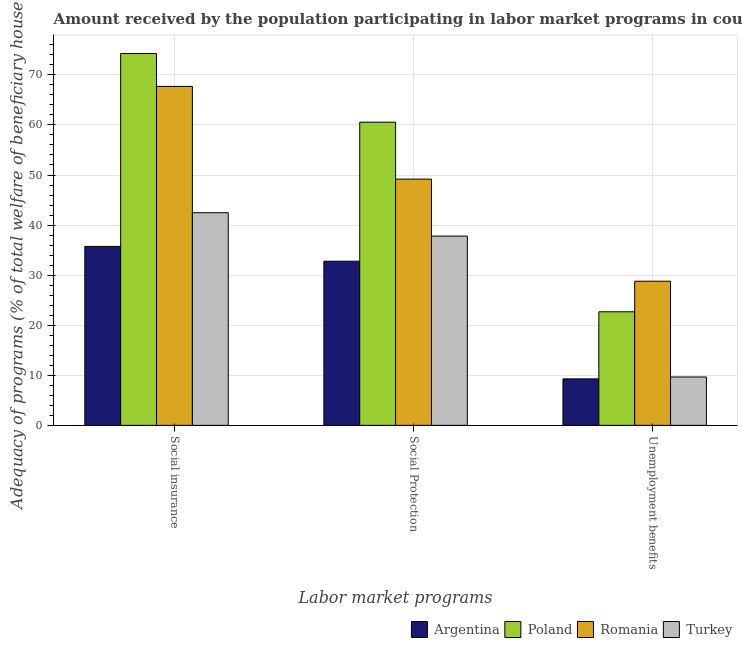Are the number of bars per tick equal to the number of legend labels?
Keep it short and to the point. Yes. How many bars are there on the 2nd tick from the left?
Ensure brevity in your answer.  4. How many bars are there on the 2nd tick from the right?
Your response must be concise. 4. What is the label of the 1st group of bars from the left?
Offer a very short reply. Social insurance. What is the amount received by the population participating in unemployment benefits programs in Turkey?
Offer a very short reply. 9.66. Across all countries, what is the maximum amount received by the population participating in social protection programs?
Your answer should be compact. 60.56. Across all countries, what is the minimum amount received by the population participating in unemployment benefits programs?
Your answer should be very brief. 9.28. In which country was the amount received by the population participating in social protection programs maximum?
Ensure brevity in your answer.  Poland. What is the total amount received by the population participating in unemployment benefits programs in the graph?
Offer a very short reply. 70.42. What is the difference between the amount received by the population participating in unemployment benefits programs in Turkey and that in Argentina?
Your answer should be very brief. 0.38. What is the difference between the amount received by the population participating in social protection programs in Argentina and the amount received by the population participating in unemployment benefits programs in Romania?
Your answer should be very brief. 4. What is the average amount received by the population participating in social insurance programs per country?
Make the answer very short. 55.05. What is the difference between the amount received by the population participating in unemployment benefits programs and amount received by the population participating in social insurance programs in Argentina?
Your response must be concise. -26.46. In how many countries, is the amount received by the population participating in unemployment benefits programs greater than 56 %?
Your answer should be compact. 0. What is the ratio of the amount received by the population participating in unemployment benefits programs in Romania to that in Argentina?
Ensure brevity in your answer.  3.1. What is the difference between the highest and the second highest amount received by the population participating in unemployment benefits programs?
Provide a succinct answer. 6.11. What is the difference between the highest and the lowest amount received by the population participating in social insurance programs?
Your answer should be very brief. 38.54. What does the 4th bar from the left in Unemployment benefits represents?
Give a very brief answer. Turkey. Is it the case that in every country, the sum of the amount received by the population participating in social insurance programs and amount received by the population participating in social protection programs is greater than the amount received by the population participating in unemployment benefits programs?
Make the answer very short. Yes. How many bars are there?
Your answer should be very brief. 12. Does the graph contain grids?
Your response must be concise. Yes. How are the legend labels stacked?
Ensure brevity in your answer.  Horizontal. What is the title of the graph?
Give a very brief answer. Amount received by the population participating in labor market programs in countries. What is the label or title of the X-axis?
Provide a short and direct response. Labor market programs. What is the label or title of the Y-axis?
Make the answer very short. Adequacy of programs (% of total welfare of beneficiary households). What is the Adequacy of programs (% of total welfare of beneficiary households) in Argentina in Social insurance?
Make the answer very short. 35.74. What is the Adequacy of programs (% of total welfare of beneficiary households) in Poland in Social insurance?
Provide a short and direct response. 74.28. What is the Adequacy of programs (% of total welfare of beneficiary households) of Romania in Social insurance?
Keep it short and to the point. 67.7. What is the Adequacy of programs (% of total welfare of beneficiary households) of Turkey in Social insurance?
Your response must be concise. 42.47. What is the Adequacy of programs (% of total welfare of beneficiary households) of Argentina in Social Protection?
Your answer should be compact. 32.79. What is the Adequacy of programs (% of total welfare of beneficiary households) in Poland in Social Protection?
Give a very brief answer. 60.56. What is the Adequacy of programs (% of total welfare of beneficiary households) of Romania in Social Protection?
Your answer should be very brief. 49.18. What is the Adequacy of programs (% of total welfare of beneficiary households) of Turkey in Social Protection?
Offer a very short reply. 37.8. What is the Adequacy of programs (% of total welfare of beneficiary households) of Argentina in Unemployment benefits?
Your answer should be very brief. 9.28. What is the Adequacy of programs (% of total welfare of beneficiary households) of Poland in Unemployment benefits?
Your answer should be very brief. 22.68. What is the Adequacy of programs (% of total welfare of beneficiary households) in Romania in Unemployment benefits?
Your answer should be very brief. 28.79. What is the Adequacy of programs (% of total welfare of beneficiary households) in Turkey in Unemployment benefits?
Make the answer very short. 9.66. Across all Labor market programs, what is the maximum Adequacy of programs (% of total welfare of beneficiary households) in Argentina?
Ensure brevity in your answer.  35.74. Across all Labor market programs, what is the maximum Adequacy of programs (% of total welfare of beneficiary households) in Poland?
Provide a succinct answer. 74.28. Across all Labor market programs, what is the maximum Adequacy of programs (% of total welfare of beneficiary households) of Romania?
Your answer should be compact. 67.7. Across all Labor market programs, what is the maximum Adequacy of programs (% of total welfare of beneficiary households) of Turkey?
Your answer should be compact. 42.47. Across all Labor market programs, what is the minimum Adequacy of programs (% of total welfare of beneficiary households) in Argentina?
Offer a very short reply. 9.28. Across all Labor market programs, what is the minimum Adequacy of programs (% of total welfare of beneficiary households) of Poland?
Ensure brevity in your answer.  22.68. Across all Labor market programs, what is the minimum Adequacy of programs (% of total welfare of beneficiary households) of Romania?
Your answer should be compact. 28.79. Across all Labor market programs, what is the minimum Adequacy of programs (% of total welfare of beneficiary households) in Turkey?
Your answer should be compact. 9.66. What is the total Adequacy of programs (% of total welfare of beneficiary households) in Argentina in the graph?
Provide a short and direct response. 77.81. What is the total Adequacy of programs (% of total welfare of beneficiary households) in Poland in the graph?
Provide a short and direct response. 157.51. What is the total Adequacy of programs (% of total welfare of beneficiary households) of Romania in the graph?
Your answer should be compact. 145.67. What is the total Adequacy of programs (% of total welfare of beneficiary households) in Turkey in the graph?
Offer a terse response. 89.93. What is the difference between the Adequacy of programs (% of total welfare of beneficiary households) in Argentina in Social insurance and that in Social Protection?
Keep it short and to the point. 2.95. What is the difference between the Adequacy of programs (% of total welfare of beneficiary households) of Poland in Social insurance and that in Social Protection?
Keep it short and to the point. 13.72. What is the difference between the Adequacy of programs (% of total welfare of beneficiary households) in Romania in Social insurance and that in Social Protection?
Keep it short and to the point. 18.51. What is the difference between the Adequacy of programs (% of total welfare of beneficiary households) in Turkey in Social insurance and that in Social Protection?
Make the answer very short. 4.67. What is the difference between the Adequacy of programs (% of total welfare of beneficiary households) in Argentina in Social insurance and that in Unemployment benefits?
Your answer should be very brief. 26.46. What is the difference between the Adequacy of programs (% of total welfare of beneficiary households) in Poland in Social insurance and that in Unemployment benefits?
Ensure brevity in your answer.  51.59. What is the difference between the Adequacy of programs (% of total welfare of beneficiary households) of Romania in Social insurance and that in Unemployment benefits?
Offer a terse response. 38.91. What is the difference between the Adequacy of programs (% of total welfare of beneficiary households) of Turkey in Social insurance and that in Unemployment benefits?
Offer a very short reply. 32.81. What is the difference between the Adequacy of programs (% of total welfare of beneficiary households) of Argentina in Social Protection and that in Unemployment benefits?
Give a very brief answer. 23.5. What is the difference between the Adequacy of programs (% of total welfare of beneficiary households) of Poland in Social Protection and that in Unemployment benefits?
Provide a short and direct response. 37.87. What is the difference between the Adequacy of programs (% of total welfare of beneficiary households) of Romania in Social Protection and that in Unemployment benefits?
Keep it short and to the point. 20.4. What is the difference between the Adequacy of programs (% of total welfare of beneficiary households) in Turkey in Social Protection and that in Unemployment benefits?
Offer a very short reply. 28.14. What is the difference between the Adequacy of programs (% of total welfare of beneficiary households) in Argentina in Social insurance and the Adequacy of programs (% of total welfare of beneficiary households) in Poland in Social Protection?
Make the answer very short. -24.82. What is the difference between the Adequacy of programs (% of total welfare of beneficiary households) in Argentina in Social insurance and the Adequacy of programs (% of total welfare of beneficiary households) in Romania in Social Protection?
Provide a succinct answer. -13.45. What is the difference between the Adequacy of programs (% of total welfare of beneficiary households) of Argentina in Social insurance and the Adequacy of programs (% of total welfare of beneficiary households) of Turkey in Social Protection?
Offer a terse response. -2.06. What is the difference between the Adequacy of programs (% of total welfare of beneficiary households) in Poland in Social insurance and the Adequacy of programs (% of total welfare of beneficiary households) in Romania in Social Protection?
Offer a terse response. 25.09. What is the difference between the Adequacy of programs (% of total welfare of beneficiary households) of Poland in Social insurance and the Adequacy of programs (% of total welfare of beneficiary households) of Turkey in Social Protection?
Make the answer very short. 36.48. What is the difference between the Adequacy of programs (% of total welfare of beneficiary households) in Romania in Social insurance and the Adequacy of programs (% of total welfare of beneficiary households) in Turkey in Social Protection?
Give a very brief answer. 29.9. What is the difference between the Adequacy of programs (% of total welfare of beneficiary households) of Argentina in Social insurance and the Adequacy of programs (% of total welfare of beneficiary households) of Poland in Unemployment benefits?
Ensure brevity in your answer.  13.06. What is the difference between the Adequacy of programs (% of total welfare of beneficiary households) of Argentina in Social insurance and the Adequacy of programs (% of total welfare of beneficiary households) of Romania in Unemployment benefits?
Your response must be concise. 6.95. What is the difference between the Adequacy of programs (% of total welfare of beneficiary households) of Argentina in Social insurance and the Adequacy of programs (% of total welfare of beneficiary households) of Turkey in Unemployment benefits?
Offer a terse response. 26.08. What is the difference between the Adequacy of programs (% of total welfare of beneficiary households) of Poland in Social insurance and the Adequacy of programs (% of total welfare of beneficiary households) of Romania in Unemployment benefits?
Give a very brief answer. 45.49. What is the difference between the Adequacy of programs (% of total welfare of beneficiary households) in Poland in Social insurance and the Adequacy of programs (% of total welfare of beneficiary households) in Turkey in Unemployment benefits?
Give a very brief answer. 64.61. What is the difference between the Adequacy of programs (% of total welfare of beneficiary households) in Romania in Social insurance and the Adequacy of programs (% of total welfare of beneficiary households) in Turkey in Unemployment benefits?
Offer a very short reply. 58.03. What is the difference between the Adequacy of programs (% of total welfare of beneficiary households) in Argentina in Social Protection and the Adequacy of programs (% of total welfare of beneficiary households) in Poland in Unemployment benefits?
Keep it short and to the point. 10.1. What is the difference between the Adequacy of programs (% of total welfare of beneficiary households) of Argentina in Social Protection and the Adequacy of programs (% of total welfare of beneficiary households) of Romania in Unemployment benefits?
Provide a short and direct response. 4. What is the difference between the Adequacy of programs (% of total welfare of beneficiary households) in Argentina in Social Protection and the Adequacy of programs (% of total welfare of beneficiary households) in Turkey in Unemployment benefits?
Your response must be concise. 23.12. What is the difference between the Adequacy of programs (% of total welfare of beneficiary households) in Poland in Social Protection and the Adequacy of programs (% of total welfare of beneficiary households) in Romania in Unemployment benefits?
Keep it short and to the point. 31.77. What is the difference between the Adequacy of programs (% of total welfare of beneficiary households) in Poland in Social Protection and the Adequacy of programs (% of total welfare of beneficiary households) in Turkey in Unemployment benefits?
Make the answer very short. 50.89. What is the difference between the Adequacy of programs (% of total welfare of beneficiary households) of Romania in Social Protection and the Adequacy of programs (% of total welfare of beneficiary households) of Turkey in Unemployment benefits?
Your answer should be very brief. 39.52. What is the average Adequacy of programs (% of total welfare of beneficiary households) of Argentina per Labor market programs?
Make the answer very short. 25.94. What is the average Adequacy of programs (% of total welfare of beneficiary households) in Poland per Labor market programs?
Offer a terse response. 52.5. What is the average Adequacy of programs (% of total welfare of beneficiary households) of Romania per Labor market programs?
Your answer should be very brief. 48.56. What is the average Adequacy of programs (% of total welfare of beneficiary households) in Turkey per Labor market programs?
Make the answer very short. 29.98. What is the difference between the Adequacy of programs (% of total welfare of beneficiary households) of Argentina and Adequacy of programs (% of total welfare of beneficiary households) of Poland in Social insurance?
Your answer should be very brief. -38.54. What is the difference between the Adequacy of programs (% of total welfare of beneficiary households) of Argentina and Adequacy of programs (% of total welfare of beneficiary households) of Romania in Social insurance?
Offer a very short reply. -31.96. What is the difference between the Adequacy of programs (% of total welfare of beneficiary households) in Argentina and Adequacy of programs (% of total welfare of beneficiary households) in Turkey in Social insurance?
Make the answer very short. -6.73. What is the difference between the Adequacy of programs (% of total welfare of beneficiary households) of Poland and Adequacy of programs (% of total welfare of beneficiary households) of Romania in Social insurance?
Your answer should be compact. 6.58. What is the difference between the Adequacy of programs (% of total welfare of beneficiary households) in Poland and Adequacy of programs (% of total welfare of beneficiary households) in Turkey in Social insurance?
Your response must be concise. 31.8. What is the difference between the Adequacy of programs (% of total welfare of beneficiary households) in Romania and Adequacy of programs (% of total welfare of beneficiary households) in Turkey in Social insurance?
Ensure brevity in your answer.  25.23. What is the difference between the Adequacy of programs (% of total welfare of beneficiary households) of Argentina and Adequacy of programs (% of total welfare of beneficiary households) of Poland in Social Protection?
Provide a short and direct response. -27.77. What is the difference between the Adequacy of programs (% of total welfare of beneficiary households) of Argentina and Adequacy of programs (% of total welfare of beneficiary households) of Romania in Social Protection?
Offer a terse response. -16.4. What is the difference between the Adequacy of programs (% of total welfare of beneficiary households) of Argentina and Adequacy of programs (% of total welfare of beneficiary households) of Turkey in Social Protection?
Give a very brief answer. -5.01. What is the difference between the Adequacy of programs (% of total welfare of beneficiary households) of Poland and Adequacy of programs (% of total welfare of beneficiary households) of Romania in Social Protection?
Your answer should be compact. 11.37. What is the difference between the Adequacy of programs (% of total welfare of beneficiary households) in Poland and Adequacy of programs (% of total welfare of beneficiary households) in Turkey in Social Protection?
Keep it short and to the point. 22.76. What is the difference between the Adequacy of programs (% of total welfare of beneficiary households) in Romania and Adequacy of programs (% of total welfare of beneficiary households) in Turkey in Social Protection?
Offer a very short reply. 11.38. What is the difference between the Adequacy of programs (% of total welfare of beneficiary households) in Argentina and Adequacy of programs (% of total welfare of beneficiary households) in Poland in Unemployment benefits?
Give a very brief answer. -13.4. What is the difference between the Adequacy of programs (% of total welfare of beneficiary households) in Argentina and Adequacy of programs (% of total welfare of beneficiary households) in Romania in Unemployment benefits?
Your answer should be compact. -19.51. What is the difference between the Adequacy of programs (% of total welfare of beneficiary households) in Argentina and Adequacy of programs (% of total welfare of beneficiary households) in Turkey in Unemployment benefits?
Give a very brief answer. -0.38. What is the difference between the Adequacy of programs (% of total welfare of beneficiary households) of Poland and Adequacy of programs (% of total welfare of beneficiary households) of Romania in Unemployment benefits?
Provide a short and direct response. -6.11. What is the difference between the Adequacy of programs (% of total welfare of beneficiary households) in Poland and Adequacy of programs (% of total welfare of beneficiary households) in Turkey in Unemployment benefits?
Your response must be concise. 13.02. What is the difference between the Adequacy of programs (% of total welfare of beneficiary households) of Romania and Adequacy of programs (% of total welfare of beneficiary households) of Turkey in Unemployment benefits?
Offer a very short reply. 19.12. What is the ratio of the Adequacy of programs (% of total welfare of beneficiary households) of Argentina in Social insurance to that in Social Protection?
Offer a very short reply. 1.09. What is the ratio of the Adequacy of programs (% of total welfare of beneficiary households) of Poland in Social insurance to that in Social Protection?
Your answer should be very brief. 1.23. What is the ratio of the Adequacy of programs (% of total welfare of beneficiary households) in Romania in Social insurance to that in Social Protection?
Provide a succinct answer. 1.38. What is the ratio of the Adequacy of programs (% of total welfare of beneficiary households) of Turkey in Social insurance to that in Social Protection?
Keep it short and to the point. 1.12. What is the ratio of the Adequacy of programs (% of total welfare of beneficiary households) of Argentina in Social insurance to that in Unemployment benefits?
Your answer should be compact. 3.85. What is the ratio of the Adequacy of programs (% of total welfare of beneficiary households) in Poland in Social insurance to that in Unemployment benefits?
Give a very brief answer. 3.27. What is the ratio of the Adequacy of programs (% of total welfare of beneficiary households) in Romania in Social insurance to that in Unemployment benefits?
Your response must be concise. 2.35. What is the ratio of the Adequacy of programs (% of total welfare of beneficiary households) of Turkey in Social insurance to that in Unemployment benefits?
Offer a terse response. 4.39. What is the ratio of the Adequacy of programs (% of total welfare of beneficiary households) of Argentina in Social Protection to that in Unemployment benefits?
Keep it short and to the point. 3.53. What is the ratio of the Adequacy of programs (% of total welfare of beneficiary households) in Poland in Social Protection to that in Unemployment benefits?
Give a very brief answer. 2.67. What is the ratio of the Adequacy of programs (% of total welfare of beneficiary households) of Romania in Social Protection to that in Unemployment benefits?
Offer a very short reply. 1.71. What is the ratio of the Adequacy of programs (% of total welfare of beneficiary households) in Turkey in Social Protection to that in Unemployment benefits?
Your answer should be very brief. 3.91. What is the difference between the highest and the second highest Adequacy of programs (% of total welfare of beneficiary households) of Argentina?
Provide a succinct answer. 2.95. What is the difference between the highest and the second highest Adequacy of programs (% of total welfare of beneficiary households) of Poland?
Your answer should be very brief. 13.72. What is the difference between the highest and the second highest Adequacy of programs (% of total welfare of beneficiary households) of Romania?
Give a very brief answer. 18.51. What is the difference between the highest and the second highest Adequacy of programs (% of total welfare of beneficiary households) in Turkey?
Offer a very short reply. 4.67. What is the difference between the highest and the lowest Adequacy of programs (% of total welfare of beneficiary households) of Argentina?
Keep it short and to the point. 26.46. What is the difference between the highest and the lowest Adequacy of programs (% of total welfare of beneficiary households) of Poland?
Offer a terse response. 51.59. What is the difference between the highest and the lowest Adequacy of programs (% of total welfare of beneficiary households) of Romania?
Your answer should be very brief. 38.91. What is the difference between the highest and the lowest Adequacy of programs (% of total welfare of beneficiary households) of Turkey?
Offer a terse response. 32.81. 